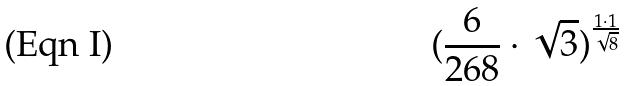Convert formula to latex. <formula><loc_0><loc_0><loc_500><loc_500>( \frac { 6 } { 2 6 8 } \cdot \sqrt { 3 } ) ^ { \frac { 1 \cdot 1 } { \sqrt { 8 } } }</formula> 